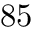Convert formula to latex. <formula><loc_0><loc_0><loc_500><loc_500>8 5</formula> 